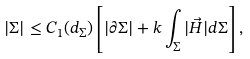Convert formula to latex. <formula><loc_0><loc_0><loc_500><loc_500>| \Sigma | \leq C _ { 1 } ( d _ { \Sigma } ) \left [ | \partial \Sigma | + k \int _ { \Sigma } | \vec { H } | d \Sigma \right ] ,</formula> 